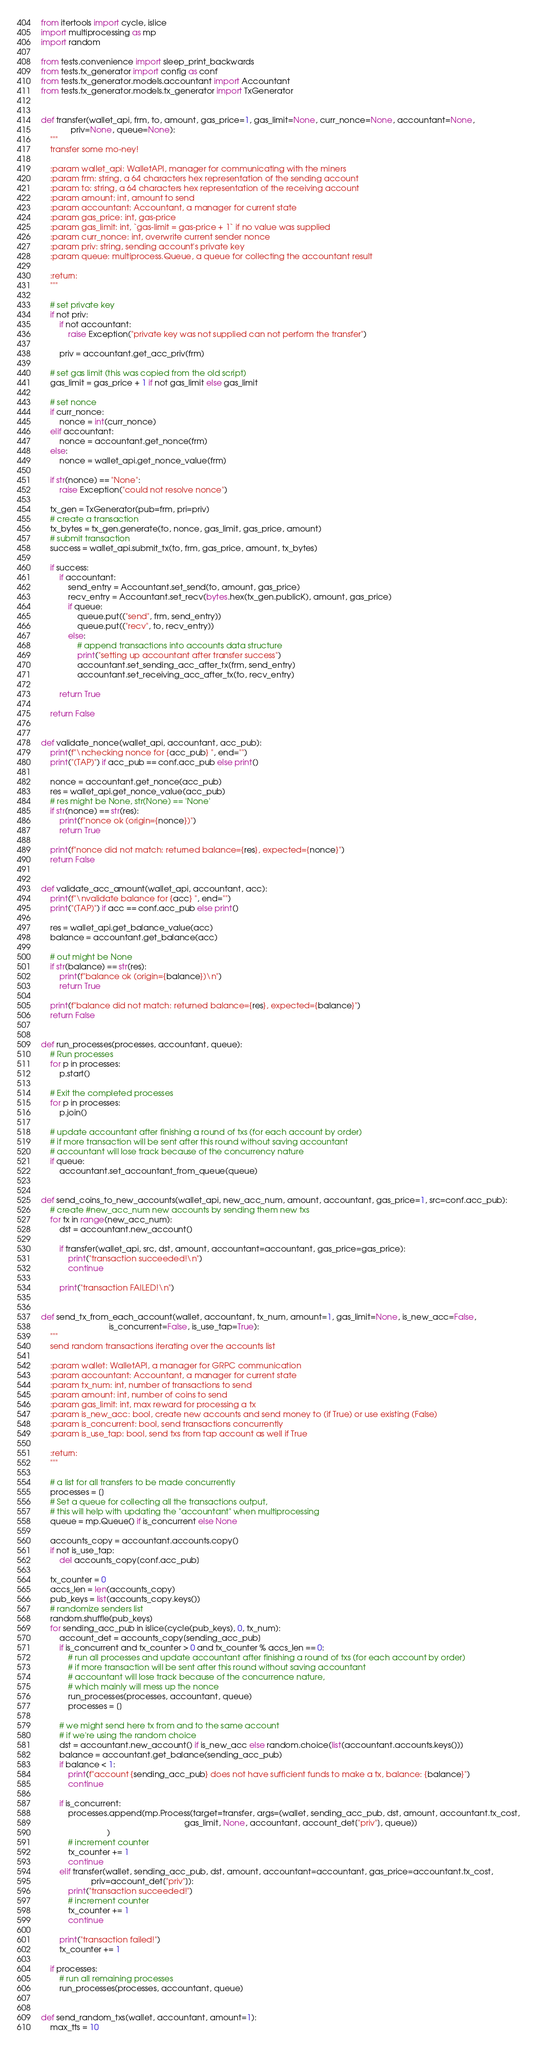Convert code to text. <code><loc_0><loc_0><loc_500><loc_500><_Python_>from itertools import cycle, islice
import multiprocessing as mp
import random

from tests.convenience import sleep_print_backwards
from tests.tx_generator import config as conf
from tests.tx_generator.models.accountant import Accountant
from tests.tx_generator.models.tx_generator import TxGenerator


def transfer(wallet_api, frm, to, amount, gas_price=1, gas_limit=None, curr_nonce=None, accountant=None,
             priv=None, queue=None):
    """
    transfer some mo-ney!

    :param wallet_api: WalletAPI, manager for communicating with the miners
    :param frm: string, a 64 characters hex representation of the sending account
    :param to: string, a 64 characters hex representation of the receiving account
    :param amount: int, amount to send
    :param accountant: Accountant, a manager for current state
    :param gas_price: int, gas-price
    :param gas_limit: int, `gas-limit = gas-price + 1` if no value was supplied
    :param curr_nonce: int, overwrite current sender nonce
    :param priv: string, sending account's private key
    :param queue: multiprocess.Queue, a queue for collecting the accountant result

    :return:
    """

    # set private key
    if not priv:
        if not accountant:
            raise Exception("private key was not supplied can not perform the transfer")

        priv = accountant.get_acc_priv(frm)

    # set gas limit (this was copied from the old script)
    gas_limit = gas_price + 1 if not gas_limit else gas_limit

    # set nonce
    if curr_nonce:
        nonce = int(curr_nonce)
    elif accountant:
        nonce = accountant.get_nonce(frm)
    else:
        nonce = wallet_api.get_nonce_value(frm)

    if str(nonce) == "None":
        raise Exception("could not resolve nonce")

    tx_gen = TxGenerator(pub=frm, pri=priv)
    # create a transaction
    tx_bytes = tx_gen.generate(to, nonce, gas_limit, gas_price, amount)
    # submit transaction
    success = wallet_api.submit_tx(to, frm, gas_price, amount, tx_bytes)

    if success:
        if accountant:
            send_entry = Accountant.set_send(to, amount, gas_price)
            recv_entry = Accountant.set_recv(bytes.hex(tx_gen.publicK), amount, gas_price)
            if queue:
                queue.put(("send", frm, send_entry))
                queue.put(("recv", to, recv_entry))
            else:
                # append transactions into accounts data structure
                print("setting up accountant after transfer success")
                accountant.set_sending_acc_after_tx(frm, send_entry)
                accountant.set_receiving_acc_after_tx(to, recv_entry)

        return True

    return False


def validate_nonce(wallet_api, accountant, acc_pub):
    print(f"\nchecking nonce for {acc_pub} ", end="")
    print("(TAP)") if acc_pub == conf.acc_pub else print()

    nonce = accountant.get_nonce(acc_pub)
    res = wallet_api.get_nonce_value(acc_pub)
    # res might be None, str(None) == 'None'
    if str(nonce) == str(res):
        print(f"nonce ok (origin={nonce})")
        return True

    print(f"nonce did not match: returned balance={res}, expected={nonce}")
    return False


def validate_acc_amount(wallet_api, accountant, acc):
    print(f"\nvalidate balance for {acc} ", end="")
    print("(TAP)") if acc == conf.acc_pub else print()

    res = wallet_api.get_balance_value(acc)
    balance = accountant.get_balance(acc)

    # out might be None
    if str(balance) == str(res):
        print(f"balance ok (origin={balance})\n")
        return True

    print(f"balance did not match: returned balance={res}, expected={balance}")
    return False


def run_processes(processes, accountant, queue):
    # Run processes
    for p in processes:
        p.start()

    # Exit the completed processes
    for p in processes:
        p.join()

    # update accountant after finishing a round of txs (for each account by order)
    # if more transaction will be sent after this round without saving accountant
    # accountant will lose track because of the concurrency nature
    if queue:
        accountant.set_accountant_from_queue(queue)


def send_coins_to_new_accounts(wallet_api, new_acc_num, amount, accountant, gas_price=1, src=conf.acc_pub):
    # create #new_acc_num new accounts by sending them new txs
    for tx in range(new_acc_num):
        dst = accountant.new_account()

        if transfer(wallet_api, src, dst, amount, accountant=accountant, gas_price=gas_price):
            print("transaction succeeded!\n")
            continue

        print("transaction FAILED!\n")


def send_tx_from_each_account(wallet, accountant, tx_num, amount=1, gas_limit=None, is_new_acc=False,
                              is_concurrent=False, is_use_tap=True):
    """
    send random transactions iterating over the accounts list

    :param wallet: WalletAPI, a manager for GRPC communication
    :param accountant: Accountant, a manager for current state
    :param tx_num: int, number of transactions to send
    :param amount: int, number of coins to send
    :param gas_limit: int, max reward for processing a tx
    :param is_new_acc: bool, create new accounts and send money to (if True) or use existing (False)
    :param is_concurrent: bool, send transactions concurrently
    :param is_use_tap: bool, send txs from tap account as well if True

    :return:
    """

    # a list for all transfers to be made concurrently
    processes = []
    # Set a queue for collecting all the transactions output,
    # this will help with updating the "accountant" when multiprocessing
    queue = mp.Queue() if is_concurrent else None

    accounts_copy = accountant.accounts.copy()
    if not is_use_tap:
        del accounts_copy[conf.acc_pub]

    tx_counter = 0
    accs_len = len(accounts_copy)
    pub_keys = list(accounts_copy.keys())
    # randomize senders list
    random.shuffle(pub_keys)
    for sending_acc_pub in islice(cycle(pub_keys), 0, tx_num):
        account_det = accounts_copy[sending_acc_pub]
        if is_concurrent and tx_counter > 0 and tx_counter % accs_len == 0:
            # run all processes and update accountant after finishing a round of txs (for each account by order)
            # if more transaction will be sent after this round without saving accountant
            # accountant will lose track because of the concurrence nature,
            # which mainly will mess up the nonce
            run_processes(processes, accountant, queue)
            processes = []

        # we might send here tx from and to the same account
        # if we're using the random choice
        dst = accountant.new_account() if is_new_acc else random.choice(list(accountant.accounts.keys()))
        balance = accountant.get_balance(sending_acc_pub)
        if balance < 1:
            print(f"account {sending_acc_pub} does not have sufficient funds to make a tx, balance: {balance}")
            continue

        if is_concurrent:
            processes.append(mp.Process(target=transfer, args=(wallet, sending_acc_pub, dst, amount, accountant.tx_cost,
                                                               gas_limit, None, accountant, account_det["priv"], queue))
                             )
            # increment counter
            tx_counter += 1
            continue
        elif transfer(wallet, sending_acc_pub, dst, amount, accountant=accountant, gas_price=accountant.tx_cost,
                      priv=account_det["priv"]):
            print("transaction succeeded!")
            # increment counter
            tx_counter += 1
            continue

        print("transaction failed!")
        tx_counter += 1

    if processes:
        # run all remaining processes
        run_processes(processes, accountant, queue)


def send_random_txs(wallet, accountant, amount=1):
    max_tts = 10</code> 